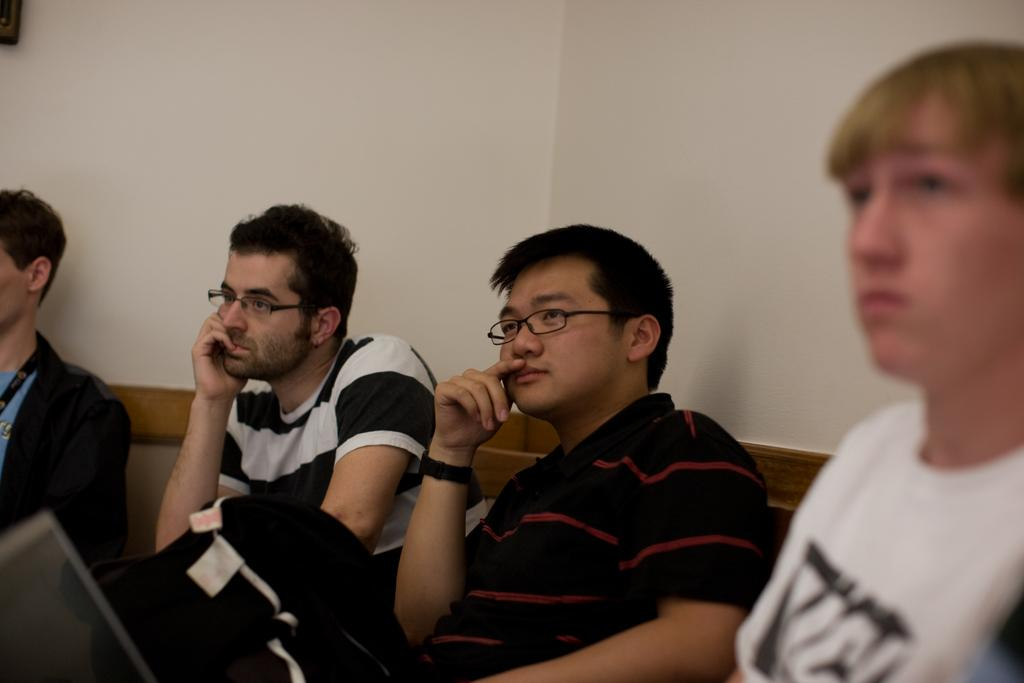What are the people in the image doing? The people in the image are sitting. What can be seen in the background of the image? There is a wall and clothes visible in the background of the image. What type of spot can be seen on the clothes in the image? There is no spot visible on the clothes in the image. How much milk is being consumed by the people in the image? There is no milk present in the image. 